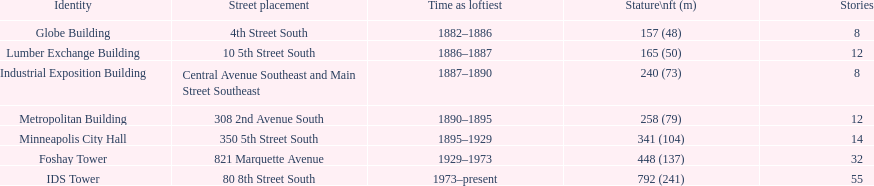What years was 240 ft considered tall? 1887–1890. What building held this record? Industrial Exposition Building. 